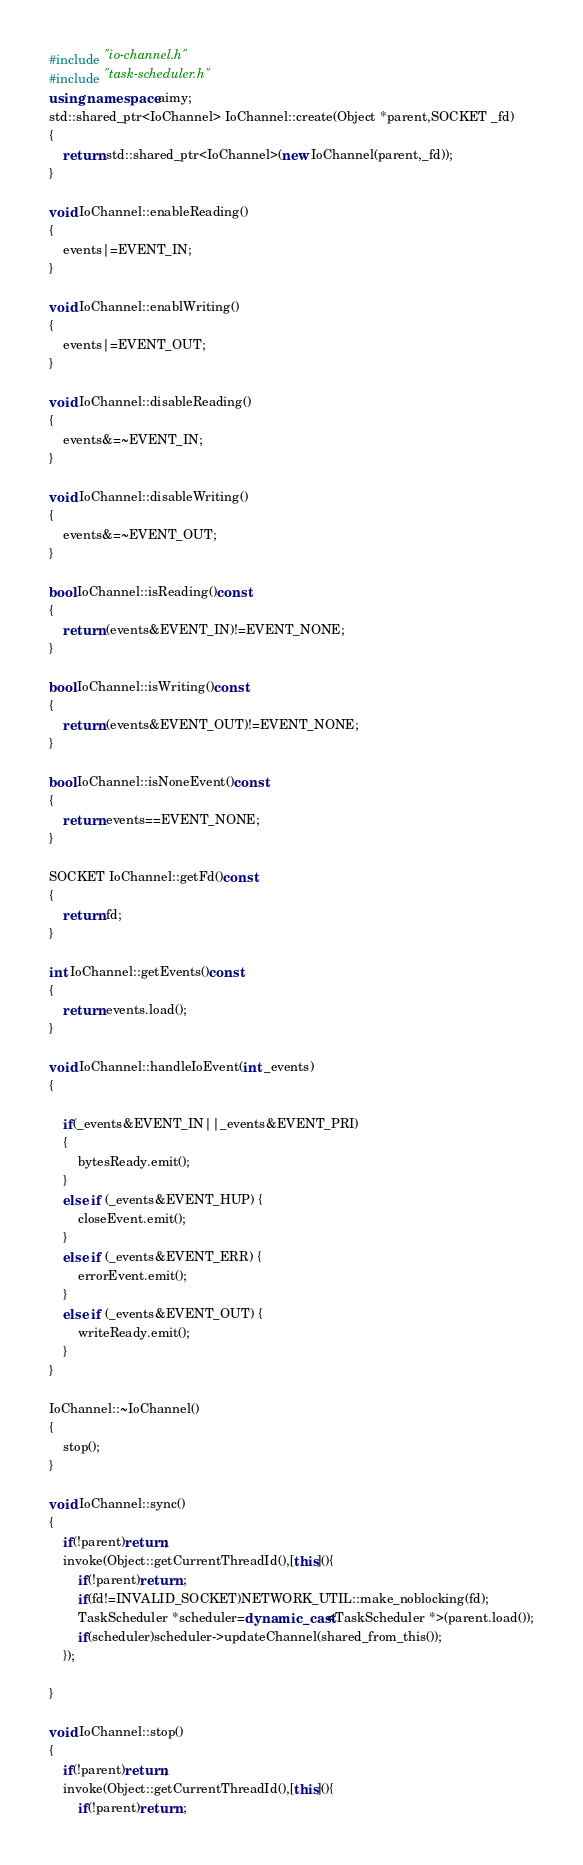Convert code to text. <code><loc_0><loc_0><loc_500><loc_500><_C++_>#include "io-channel.h"
#include "task-scheduler.h"
using namespace aimy;
std::shared_ptr<IoChannel> IoChannel::create(Object *parent,SOCKET _fd)
{
    return std::shared_ptr<IoChannel>(new IoChannel(parent,_fd));
}

void IoChannel::enableReading()
{
    events|=EVENT_IN;
}

void IoChannel::enablWriting()
{
    events|=EVENT_OUT;
}

void IoChannel::disableReading()
{
    events&=~EVENT_IN;
}

void IoChannel::disableWriting()
{
    events&=~EVENT_OUT;
}

bool IoChannel::isReading()const
{
    return (events&EVENT_IN)!=EVENT_NONE;
}

bool IoChannel::isWriting()const
{
    return (events&EVENT_OUT)!=EVENT_NONE;
}

bool IoChannel::isNoneEvent()const
{
    return events==EVENT_NONE;
}

SOCKET IoChannel::getFd()const
{
    return fd;
}

int IoChannel::getEvents()const
{
    return events.load();
}

void IoChannel::handleIoEvent(int _events)
{

    if(_events&EVENT_IN||_events&EVENT_PRI)
    {
        bytesReady.emit();
    }
    else if (_events&EVENT_HUP) {
        closeEvent.emit();
    }
    else if (_events&EVENT_ERR) {
        errorEvent.emit();
    }
    else if (_events&EVENT_OUT) {
        writeReady.emit();
    }
}

IoChannel::~IoChannel()
{
    stop();
}

void IoChannel::sync()
{
    if(!parent)return;
    invoke(Object::getCurrentThreadId(),[this](){
        if(!parent)return ;
        if(fd!=INVALID_SOCKET)NETWORK_UTIL::make_noblocking(fd);
        TaskScheduler *scheduler=dynamic_cast<TaskScheduler *>(parent.load());
        if(scheduler)scheduler->updateChannel(shared_from_this());
    });

}

void IoChannel::stop()
{
    if(!parent)return;
    invoke(Object::getCurrentThreadId(),[this](){
        if(!parent)return ;</code> 